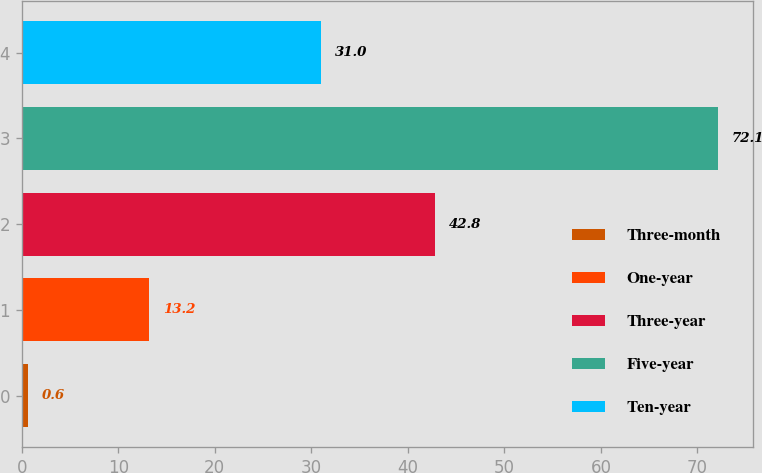Convert chart to OTSL. <chart><loc_0><loc_0><loc_500><loc_500><bar_chart><fcel>Three-month<fcel>One-year<fcel>Three-year<fcel>Five-year<fcel>Ten-year<nl><fcel>0.6<fcel>13.2<fcel>42.8<fcel>72.1<fcel>31<nl></chart> 